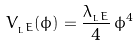<formula> <loc_0><loc_0><loc_500><loc_500>V _ { _ { L } E } ( \phi ) = \frac { \lambda _ { _ { L } E } } { 4 } \, \phi ^ { 4 }</formula> 